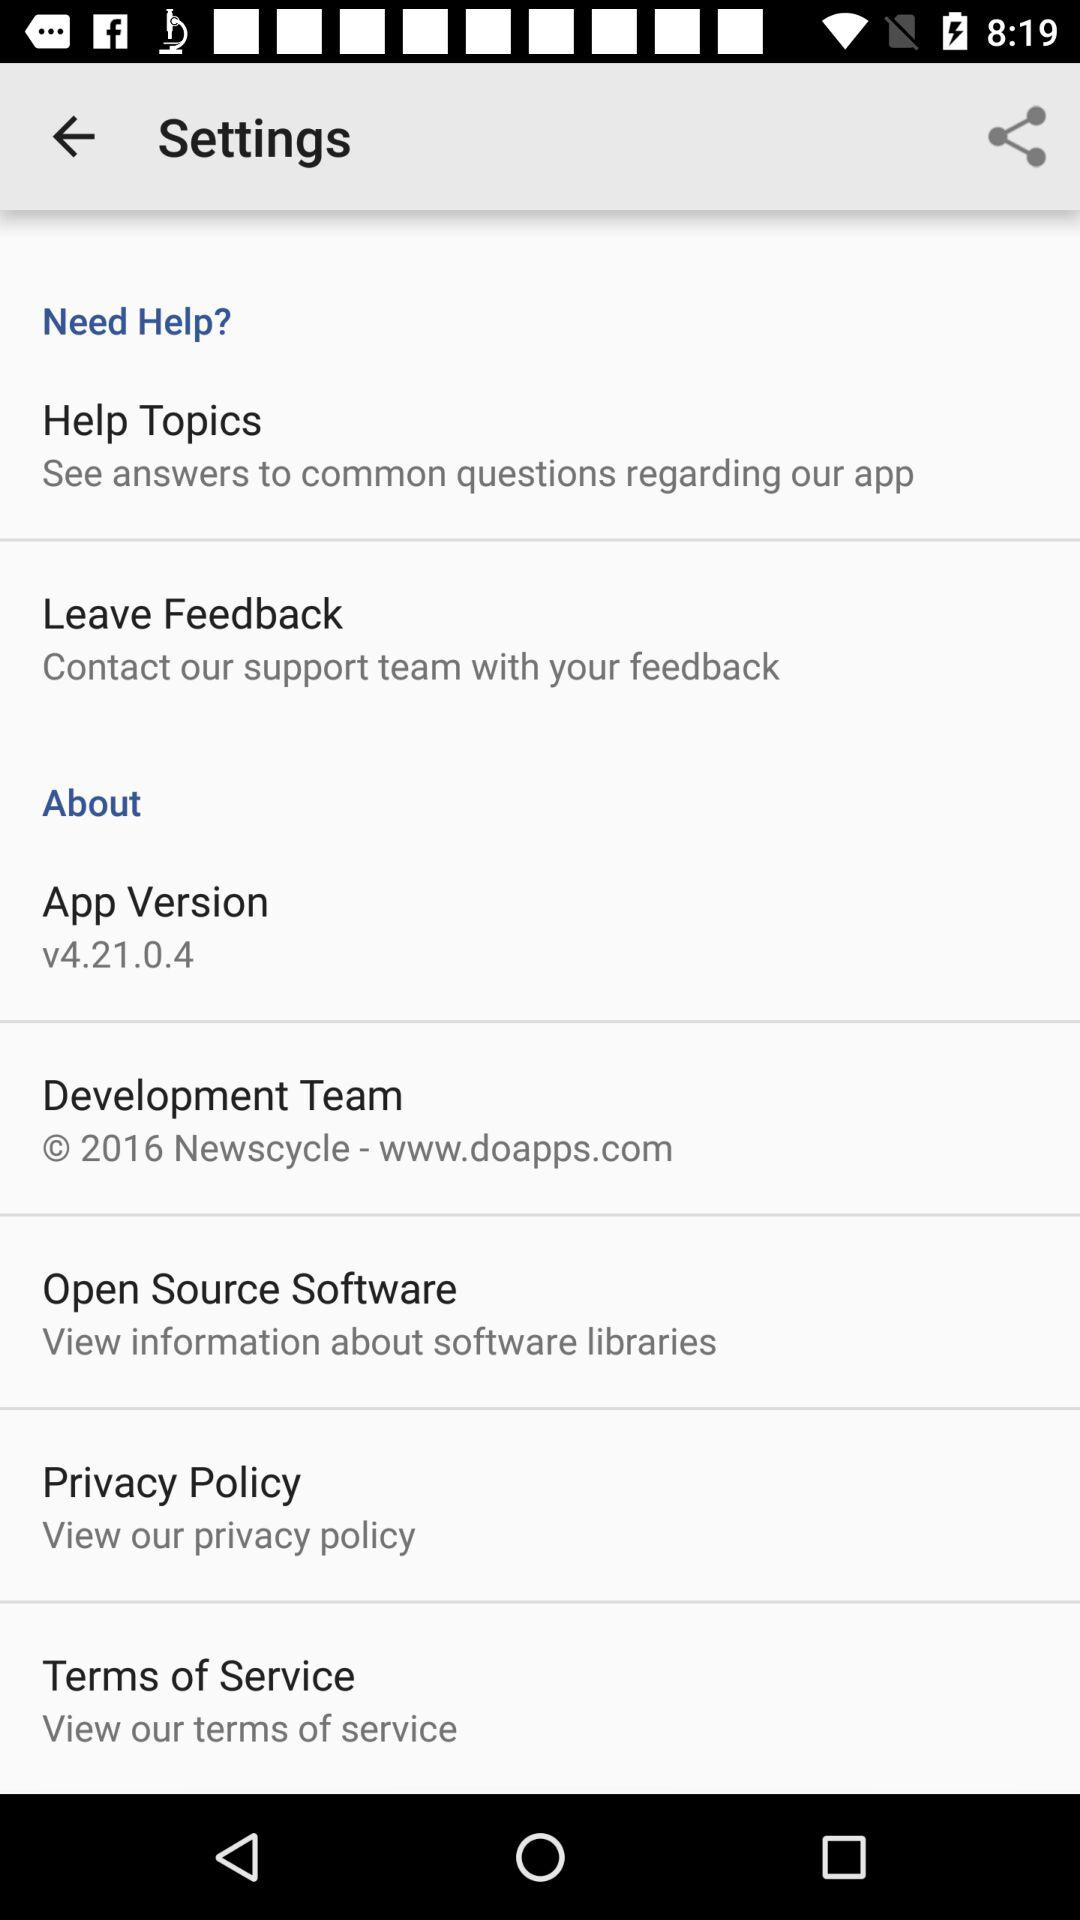What is the version? The version is v4.21.0.4. 